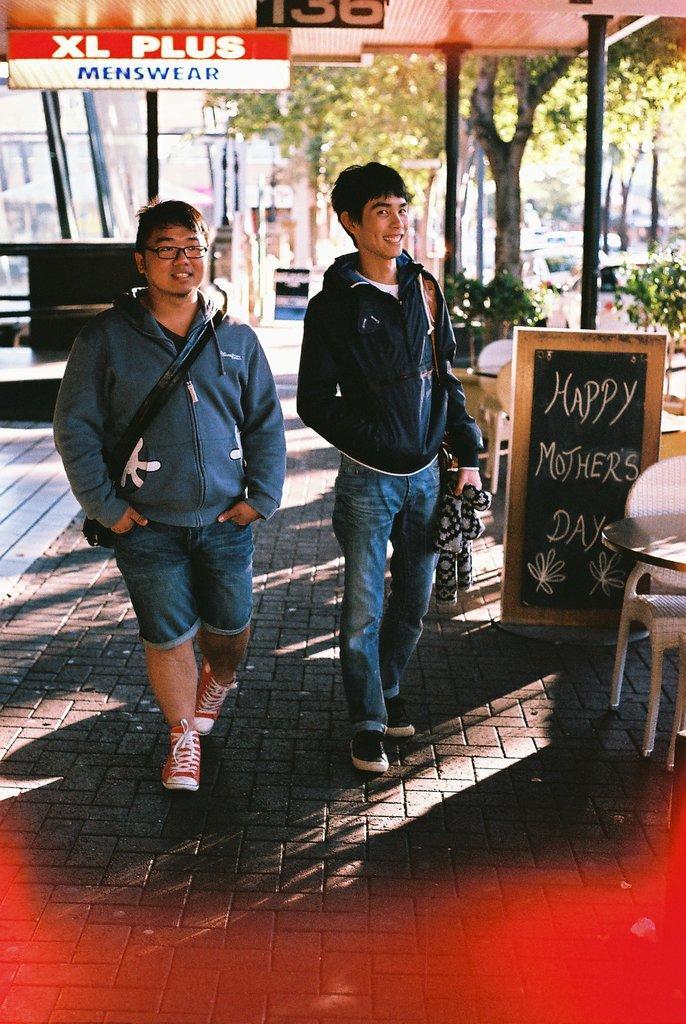Could you give a brief overview of what you see in this image? In this picture there is a man who is wearing jacket, jeans and sneakers, beside her we can see another man who is wearing spectacle, hoodie, short and shoe. On the right we can see the table, chairs and blackboard. In the background we can see many trees, buildings, cars and other objects. At the top we can see some boards which is hanged on the roof. 